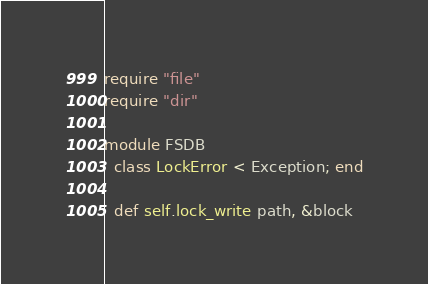Convert code to text. <code><loc_0><loc_0><loc_500><loc_500><_Crystal_>require "file"
require "dir"

module FSDB
  class LockError < Exception; end

  def self.lock_write path, &block</code> 